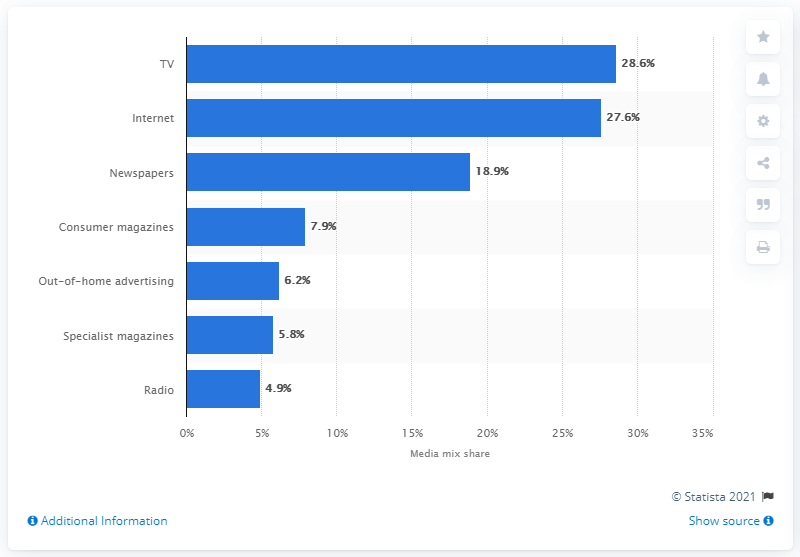Highlight a few significant elements in this photo. The total of the least four values is 24.8. Seven formats have been considered in total. In 2014, the gross advertising investment share of internet advertising in Germany was 27.6%. 